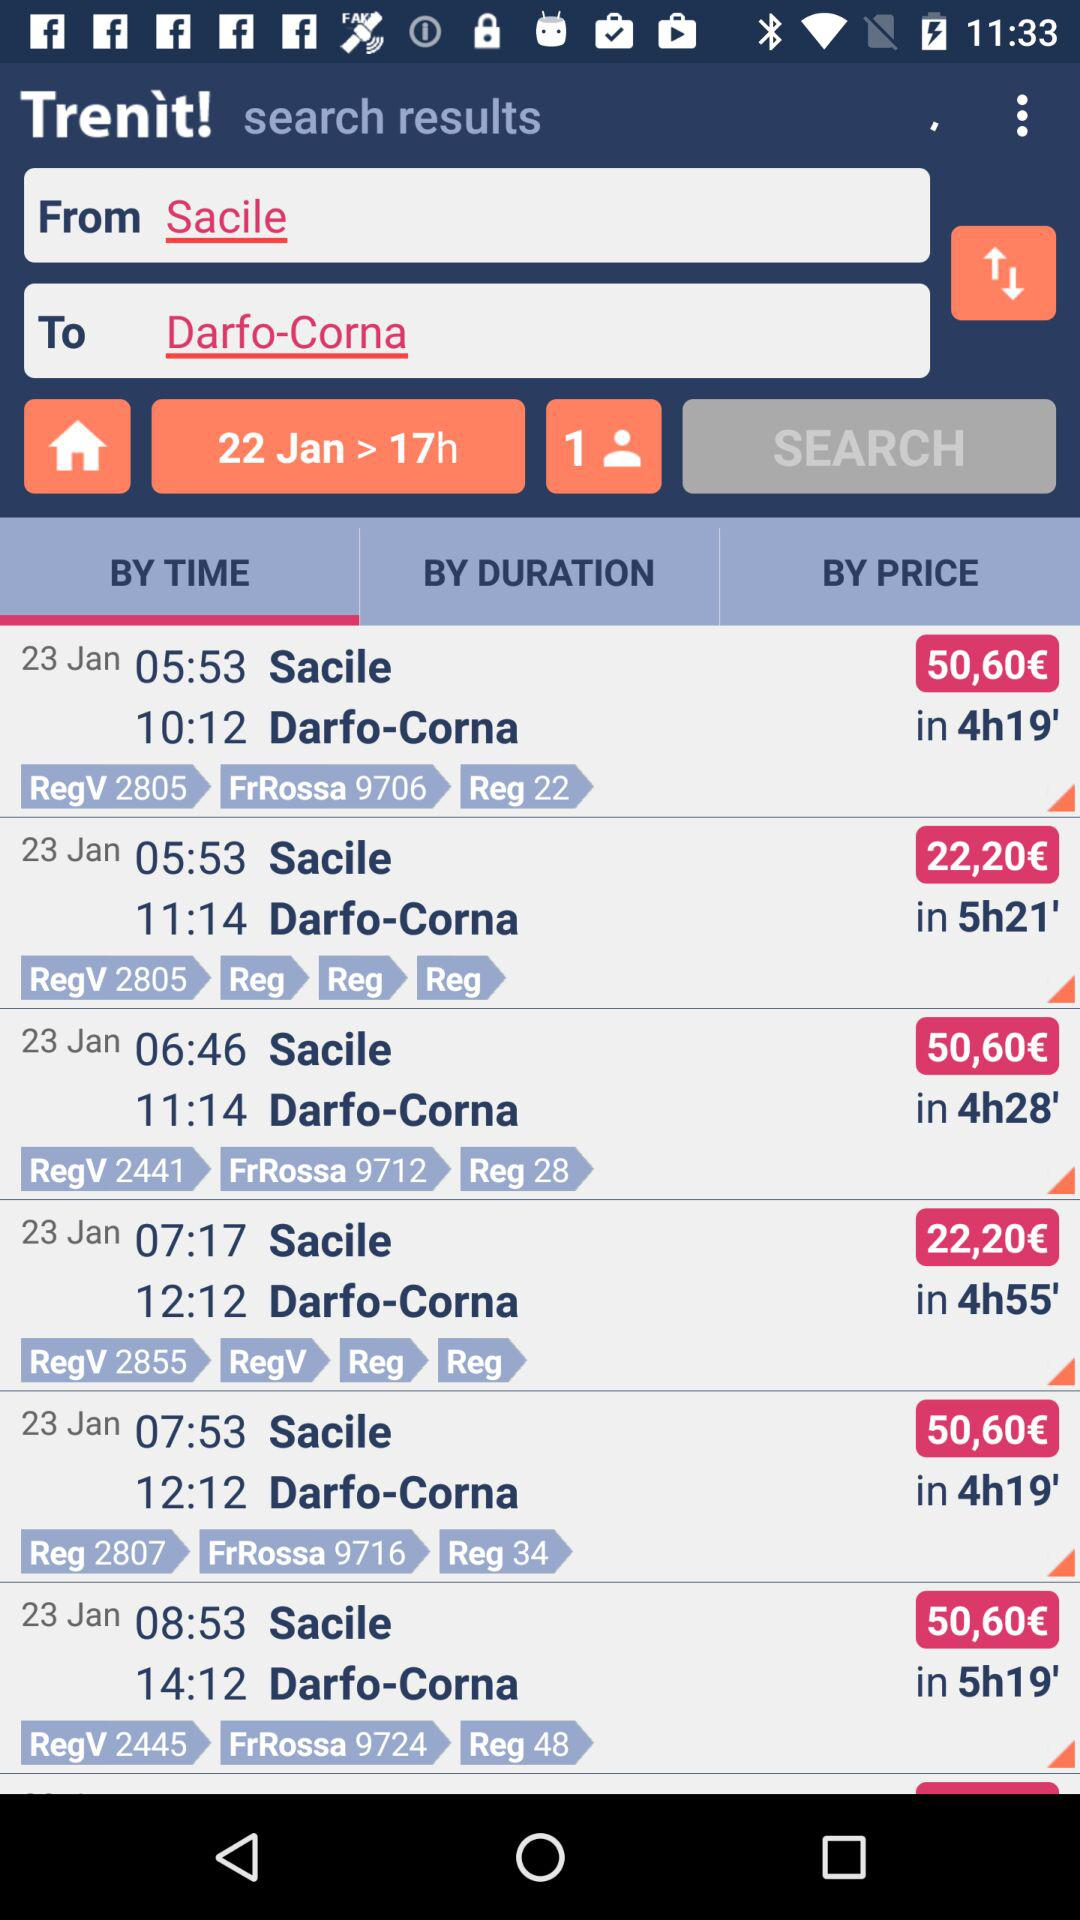What is the destination location? The destination location is Darfo-Corna. 